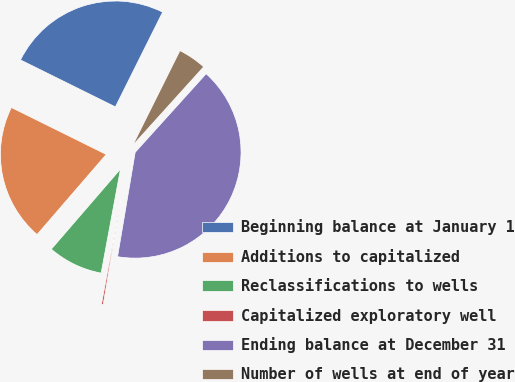Convert chart. <chart><loc_0><loc_0><loc_500><loc_500><pie_chart><fcel>Beginning balance at January 1<fcel>Additions to capitalized<fcel>Reclassifications to wells<fcel>Capitalized exploratory well<fcel>Ending balance at December 31<fcel>Number of wells at end of year<nl><fcel>25.05%<fcel>20.98%<fcel>8.41%<fcel>0.26%<fcel>40.98%<fcel>4.33%<nl></chart> 